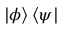<formula> <loc_0><loc_0><loc_500><loc_500>| \phi \rangle \, \langle \psi |</formula> 